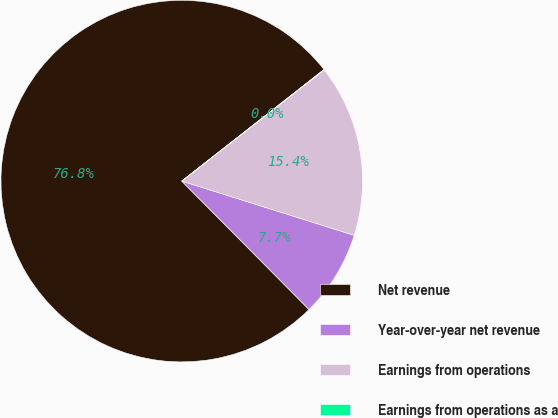Convert chart to OTSL. <chart><loc_0><loc_0><loc_500><loc_500><pie_chart><fcel>Net revenue<fcel>Year-over-year net revenue<fcel>Earnings from operations<fcel>Earnings from operations as a<nl><fcel>76.84%<fcel>7.72%<fcel>15.4%<fcel>0.04%<nl></chart> 